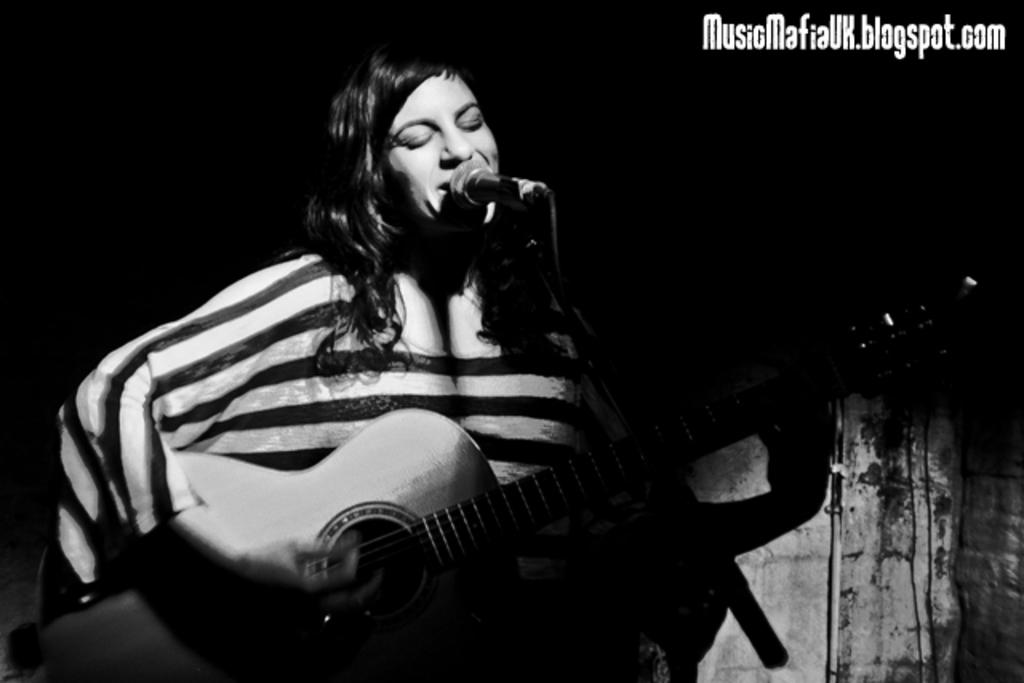Who is the main subject in the image? There is a woman in the image. What is the woman doing in the image? The woman is standing and playing the guitar. What object is the woman holding in the image? The woman is holding a guitar. What other object is present in the image? There is a microphone in the image. How does the woman turn into a maid in the image? The woman does not turn into a maid in the image; she remains a woman playing the guitar. Is there a bridge visible in the image? There is no bridge present in the image. 